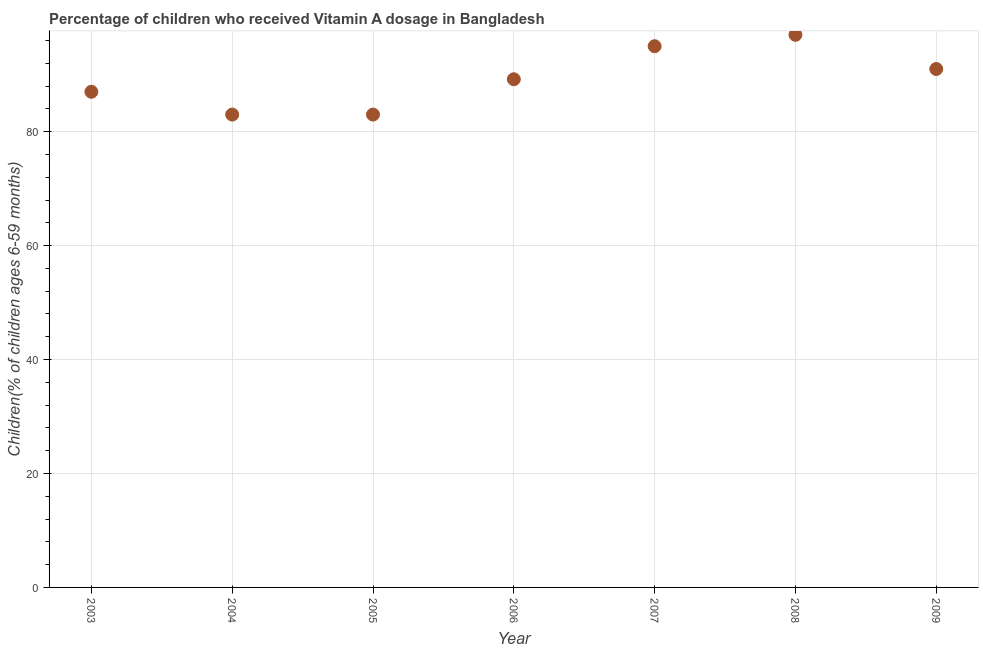What is the vitamin a supplementation coverage rate in 2007?
Provide a short and direct response. 95. Across all years, what is the maximum vitamin a supplementation coverage rate?
Your response must be concise. 97. Across all years, what is the minimum vitamin a supplementation coverage rate?
Your answer should be very brief. 83. In which year was the vitamin a supplementation coverage rate maximum?
Offer a terse response. 2008. In which year was the vitamin a supplementation coverage rate minimum?
Keep it short and to the point. 2004. What is the sum of the vitamin a supplementation coverage rate?
Offer a very short reply. 625.2. What is the difference between the vitamin a supplementation coverage rate in 2006 and 2007?
Give a very brief answer. -5.8. What is the average vitamin a supplementation coverage rate per year?
Provide a succinct answer. 89.31. What is the median vitamin a supplementation coverage rate?
Keep it short and to the point. 89.2. In how many years, is the vitamin a supplementation coverage rate greater than 28 %?
Ensure brevity in your answer.  7. What is the ratio of the vitamin a supplementation coverage rate in 2005 to that in 2007?
Keep it short and to the point. 0.87. What is the difference between the highest and the second highest vitamin a supplementation coverage rate?
Provide a short and direct response. 2. Is the sum of the vitamin a supplementation coverage rate in 2007 and 2008 greater than the maximum vitamin a supplementation coverage rate across all years?
Make the answer very short. Yes. In how many years, is the vitamin a supplementation coverage rate greater than the average vitamin a supplementation coverage rate taken over all years?
Your answer should be very brief. 3. How many dotlines are there?
Ensure brevity in your answer.  1. What is the difference between two consecutive major ticks on the Y-axis?
Give a very brief answer. 20. Does the graph contain grids?
Provide a succinct answer. Yes. What is the title of the graph?
Keep it short and to the point. Percentage of children who received Vitamin A dosage in Bangladesh. What is the label or title of the X-axis?
Ensure brevity in your answer.  Year. What is the label or title of the Y-axis?
Offer a very short reply. Children(% of children ages 6-59 months). What is the Children(% of children ages 6-59 months) in 2003?
Keep it short and to the point. 87. What is the Children(% of children ages 6-59 months) in 2004?
Offer a terse response. 83. What is the Children(% of children ages 6-59 months) in 2006?
Ensure brevity in your answer.  89.2. What is the Children(% of children ages 6-59 months) in 2008?
Ensure brevity in your answer.  97. What is the Children(% of children ages 6-59 months) in 2009?
Your answer should be compact. 91. What is the difference between the Children(% of children ages 6-59 months) in 2003 and 2005?
Provide a short and direct response. 4. What is the difference between the Children(% of children ages 6-59 months) in 2003 and 2008?
Keep it short and to the point. -10. What is the difference between the Children(% of children ages 6-59 months) in 2004 and 2005?
Your answer should be compact. 0. What is the difference between the Children(% of children ages 6-59 months) in 2004 and 2007?
Make the answer very short. -12. What is the difference between the Children(% of children ages 6-59 months) in 2004 and 2009?
Ensure brevity in your answer.  -8. What is the difference between the Children(% of children ages 6-59 months) in 2005 and 2007?
Provide a short and direct response. -12. What is the difference between the Children(% of children ages 6-59 months) in 2005 and 2009?
Provide a succinct answer. -8. What is the difference between the Children(% of children ages 6-59 months) in 2006 and 2007?
Give a very brief answer. -5.8. What is the difference between the Children(% of children ages 6-59 months) in 2006 and 2008?
Your response must be concise. -7.8. What is the difference between the Children(% of children ages 6-59 months) in 2006 and 2009?
Ensure brevity in your answer.  -1.8. What is the difference between the Children(% of children ages 6-59 months) in 2007 and 2008?
Keep it short and to the point. -2. What is the ratio of the Children(% of children ages 6-59 months) in 2003 to that in 2004?
Your answer should be very brief. 1.05. What is the ratio of the Children(% of children ages 6-59 months) in 2003 to that in 2005?
Provide a succinct answer. 1.05. What is the ratio of the Children(% of children ages 6-59 months) in 2003 to that in 2006?
Your answer should be compact. 0.97. What is the ratio of the Children(% of children ages 6-59 months) in 2003 to that in 2007?
Your answer should be compact. 0.92. What is the ratio of the Children(% of children ages 6-59 months) in 2003 to that in 2008?
Keep it short and to the point. 0.9. What is the ratio of the Children(% of children ages 6-59 months) in 2003 to that in 2009?
Offer a very short reply. 0.96. What is the ratio of the Children(% of children ages 6-59 months) in 2004 to that in 2005?
Offer a terse response. 1. What is the ratio of the Children(% of children ages 6-59 months) in 2004 to that in 2006?
Offer a terse response. 0.93. What is the ratio of the Children(% of children ages 6-59 months) in 2004 to that in 2007?
Offer a very short reply. 0.87. What is the ratio of the Children(% of children ages 6-59 months) in 2004 to that in 2008?
Offer a very short reply. 0.86. What is the ratio of the Children(% of children ages 6-59 months) in 2004 to that in 2009?
Ensure brevity in your answer.  0.91. What is the ratio of the Children(% of children ages 6-59 months) in 2005 to that in 2006?
Your response must be concise. 0.93. What is the ratio of the Children(% of children ages 6-59 months) in 2005 to that in 2007?
Your answer should be very brief. 0.87. What is the ratio of the Children(% of children ages 6-59 months) in 2005 to that in 2008?
Give a very brief answer. 0.86. What is the ratio of the Children(% of children ages 6-59 months) in 2005 to that in 2009?
Ensure brevity in your answer.  0.91. What is the ratio of the Children(% of children ages 6-59 months) in 2006 to that in 2007?
Give a very brief answer. 0.94. What is the ratio of the Children(% of children ages 6-59 months) in 2006 to that in 2008?
Offer a terse response. 0.92. What is the ratio of the Children(% of children ages 6-59 months) in 2006 to that in 2009?
Your response must be concise. 0.98. What is the ratio of the Children(% of children ages 6-59 months) in 2007 to that in 2008?
Give a very brief answer. 0.98. What is the ratio of the Children(% of children ages 6-59 months) in 2007 to that in 2009?
Your answer should be very brief. 1.04. What is the ratio of the Children(% of children ages 6-59 months) in 2008 to that in 2009?
Your response must be concise. 1.07. 